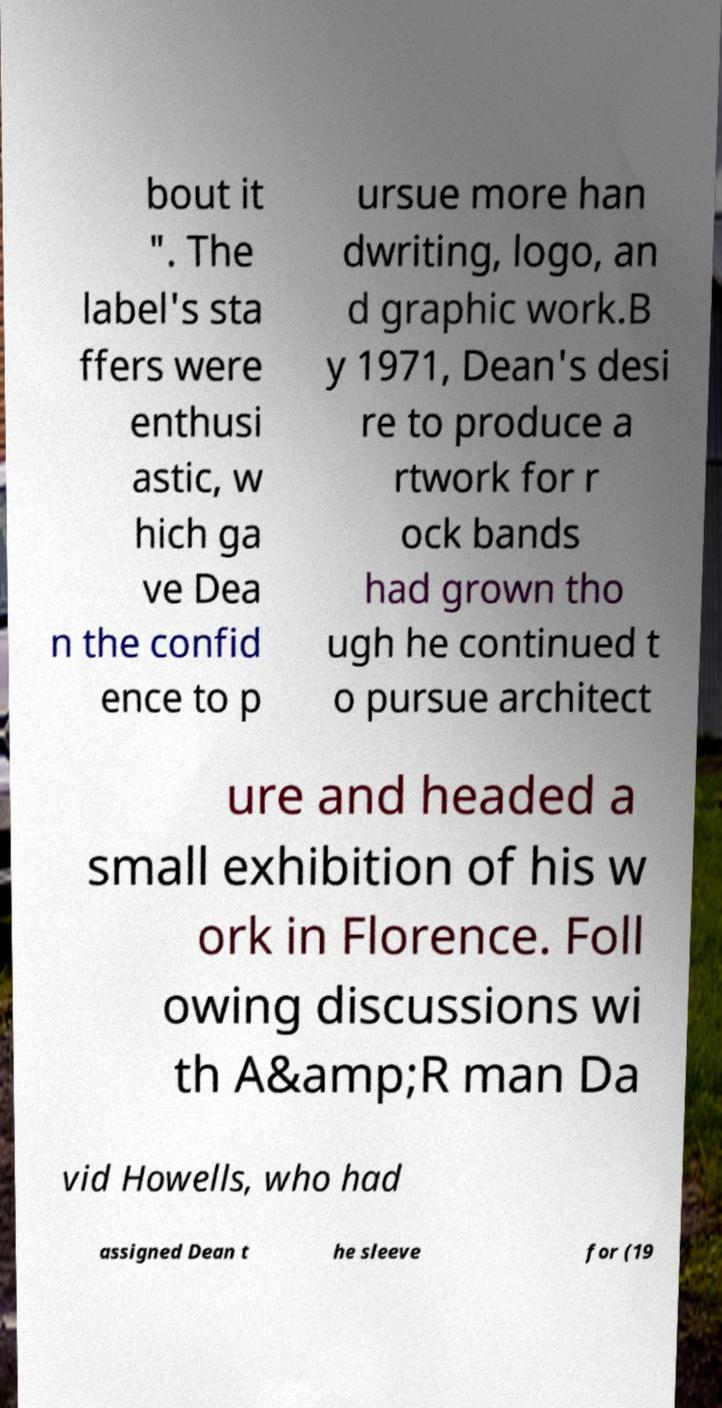For documentation purposes, I need the text within this image transcribed. Could you provide that? bout it ". The label's sta ffers were enthusi astic, w hich ga ve Dea n the confid ence to p ursue more han dwriting, logo, an d graphic work.B y 1971, Dean's desi re to produce a rtwork for r ock bands had grown tho ugh he continued t o pursue architect ure and headed a small exhibition of his w ork in Florence. Foll owing discussions wi th A&amp;R man Da vid Howells, who had assigned Dean t he sleeve for (19 